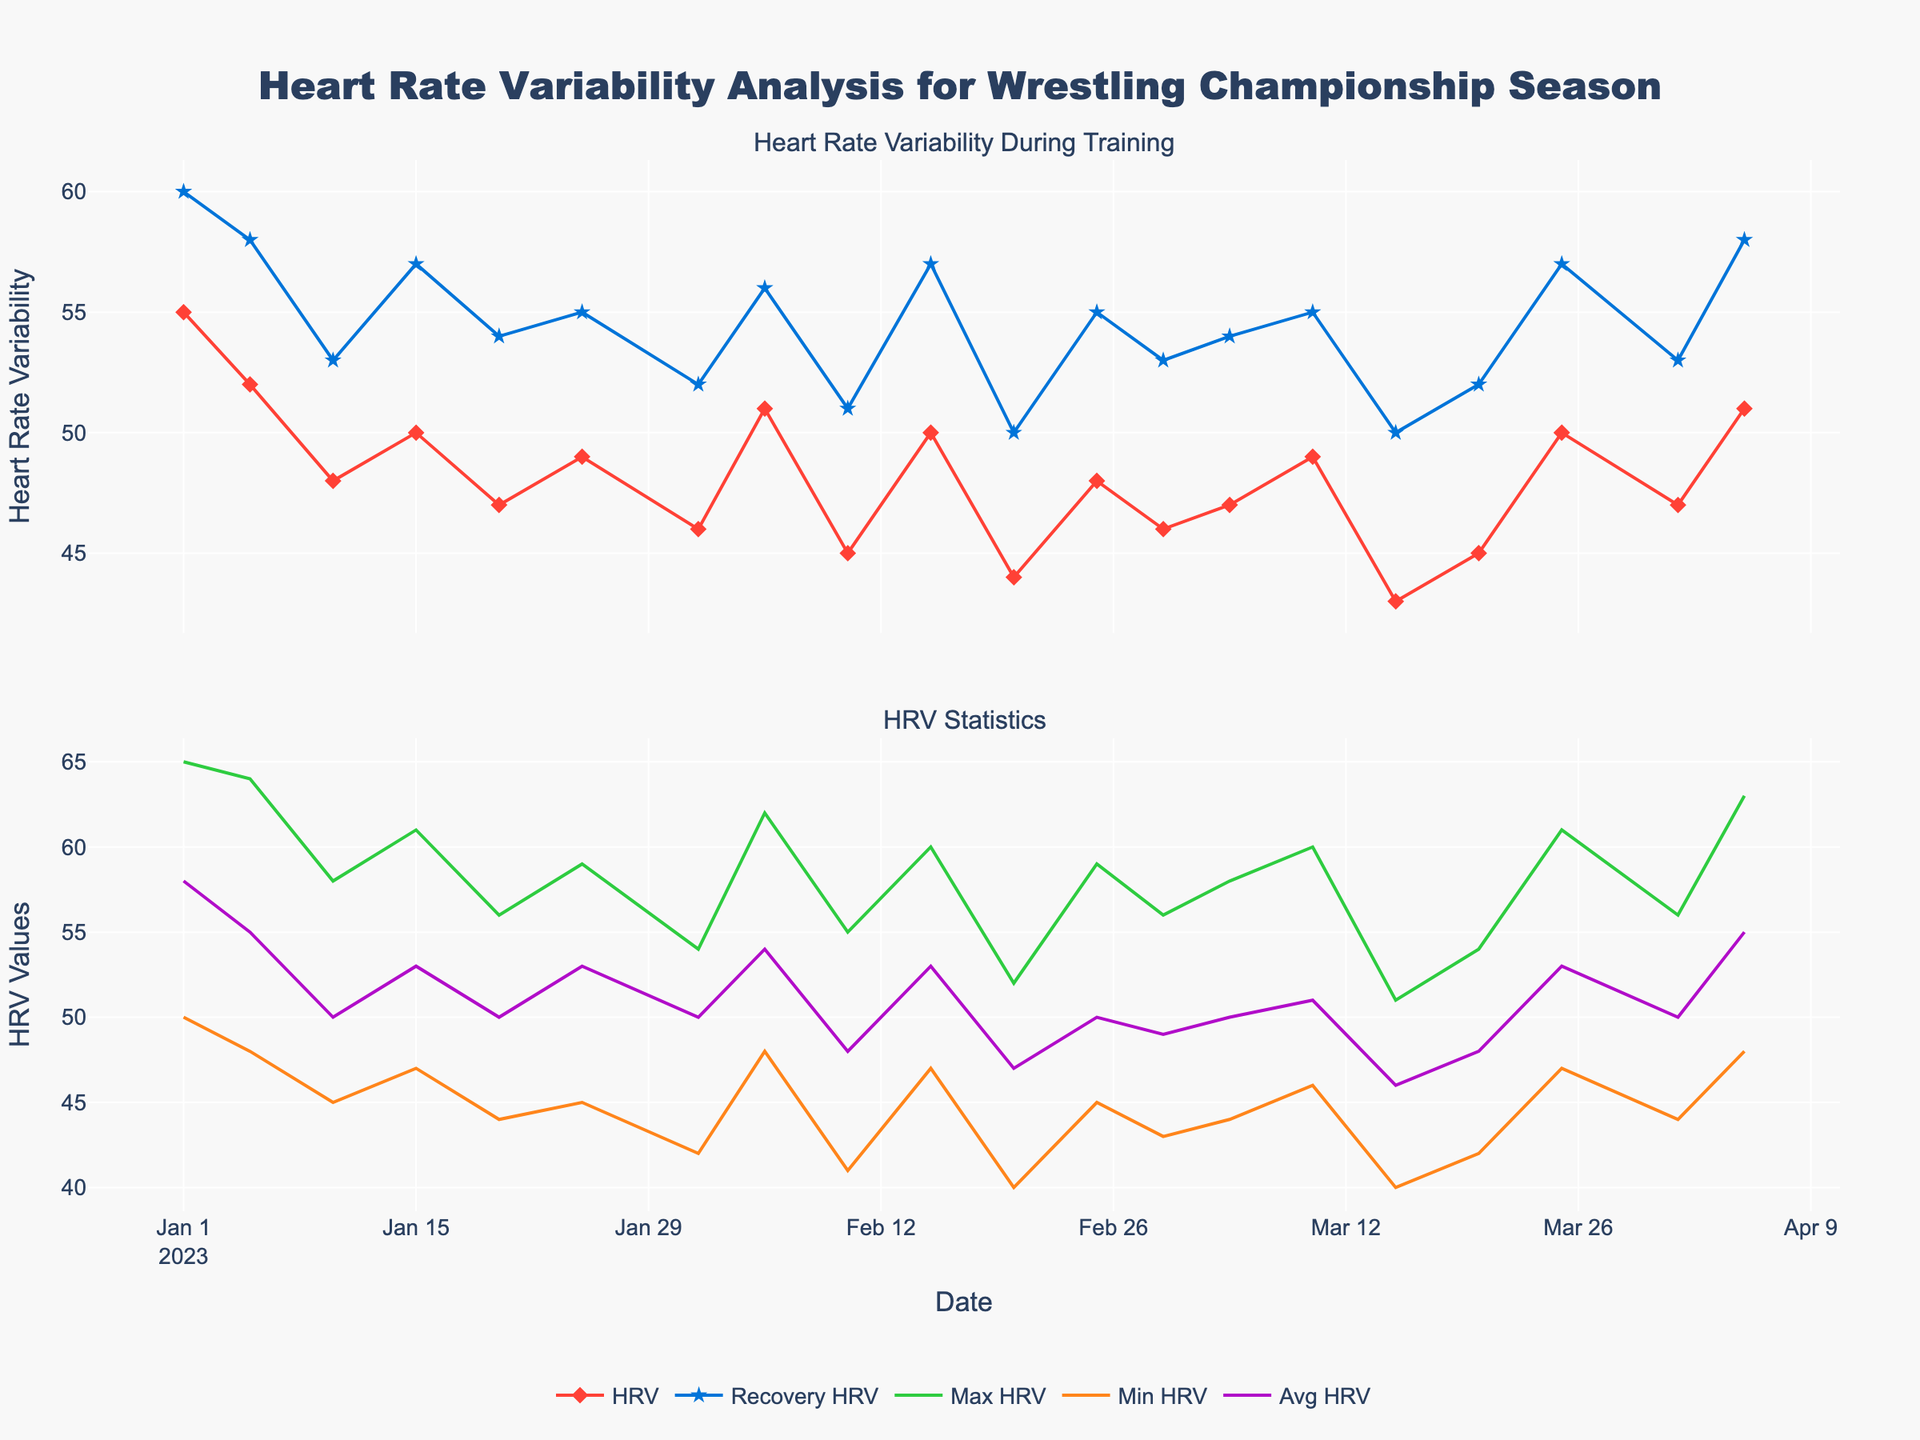What is the title of the plot? The title is clearly stated at the top of the plot, reflecting the subject of the data visualization.
Answer: Heart Rate Variability Analysis for Wrestling Championship Season How many data points are plotted for the HRV during training sessions? By counting the markers on the plot for HRV during training sessions, we can determine the number of data points.
Answer: 20 What are the highest and lowest HRV values during recovery periods? To find these, identify the highest and lowest points of the 'Recovery HRV' line in the first subplot.
Answer: Highest: 60, Lowest: 50 How does the trend of HRV during training sessions change over time? Investigate the general direction of the 'HRV' line in the first subplot to determine if it's increasing, decreasing, or fluctuating.
Answer: Fluctuating Which session shows the maximum HRV value and what is it? Locate the highest point on the 'Max HRV' line in the second subplot and note the corresponding session and HRV value.
Answer: Session 1, 65 In which training session is the minimum HRV during training the lowest, and what is the value? Identify the lowest point on the 'Min HRV' line in the second subplot and note the corresponding session and HRV value.
Answer: Session 11, 40 How does the average HRV value compare between early sessions (Sessions 1-5) and later sessions (Sessions 16-20)? Calculate the average HRV for Sessions 1-5 and compare it with the average for Sessions 16-20.
Answer: Early: 53.2, Later: 50.6 Does the recovery HRV generally stay higher, lower, or equal to the training HRV throughout the sessions? Compare the heights of the 'Recovery HRV' and 'HRV' lines at each session to determine the general relationship.
Answer: Higher What can be inferred about the athlete's recovery by analyzing the HRV differences during recovery across the training sessions? Look at the variations and consistency of 'Recovery HRV;' larger differences might indicate better or worse recovery, depending on consistency.
Answer: Generally consistent, indicating stable recovery Are there any sessions where the HRV during training and recovery are equal? If so, which one(s)? Observe the points where the 'HRV' and' Recovery HRV' lines intersect.
Answer: No sessions are equal 